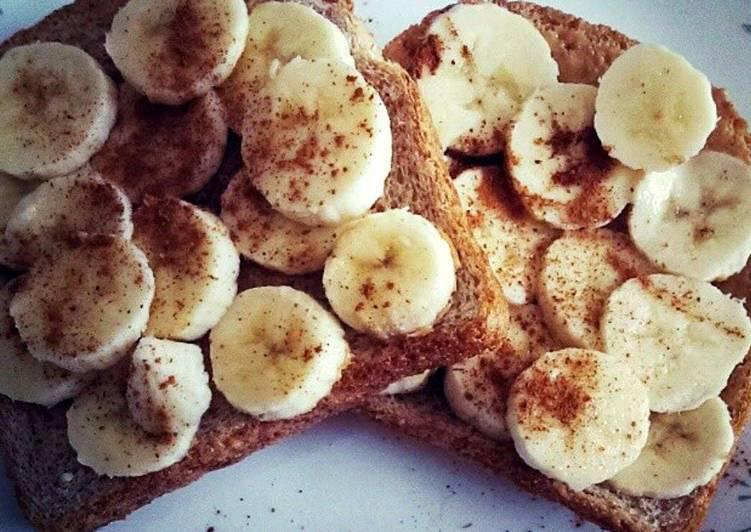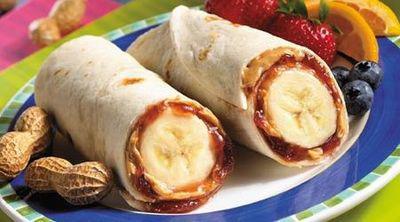The first image is the image on the left, the second image is the image on the right. Given the left and right images, does the statement "There are at least five pieces of bread with pieces of banana on them." hold true? Answer yes or no. No. The first image is the image on the left, the second image is the image on the right. For the images displayed, is the sentence "Twenty one or fewer banana slices are visible." factually correct? Answer yes or no. No. 